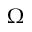<formula> <loc_0><loc_0><loc_500><loc_500>\Omega</formula> 